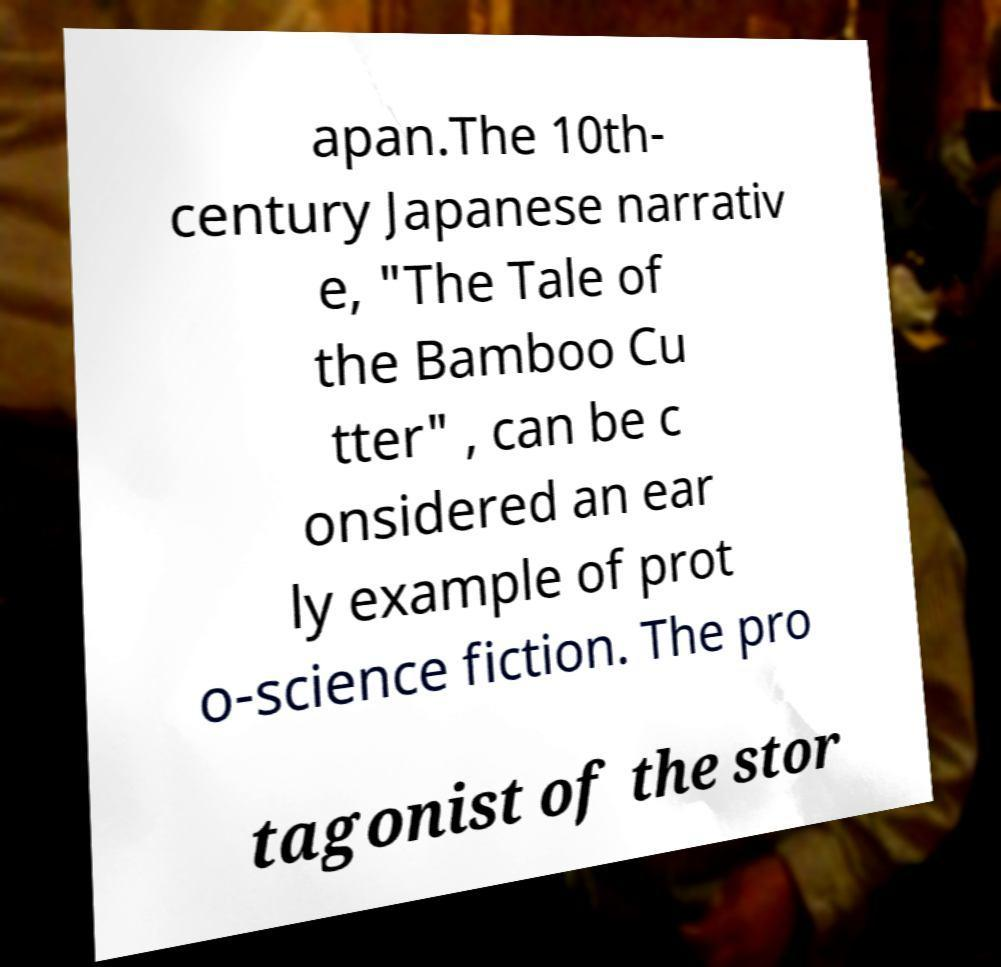There's text embedded in this image that I need extracted. Can you transcribe it verbatim? apan.The 10th- century Japanese narrativ e, "The Tale of the Bamboo Cu tter" , can be c onsidered an ear ly example of prot o-science fiction. The pro tagonist of the stor 